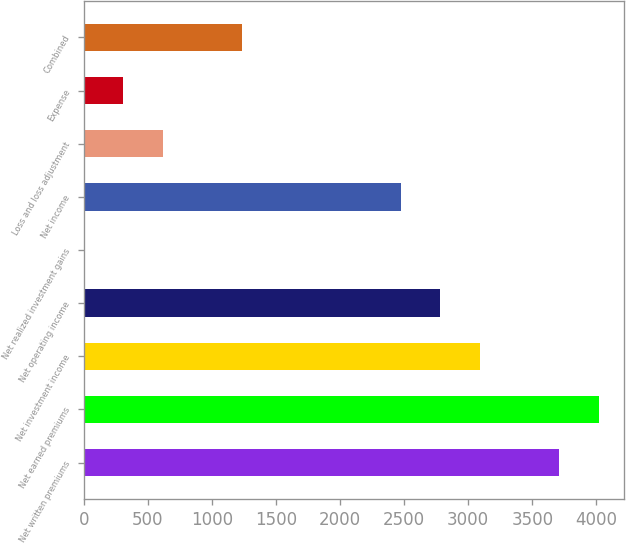Convert chart. <chart><loc_0><loc_0><loc_500><loc_500><bar_chart><fcel>Net written premiums<fcel>Net earned premiums<fcel>Net investment income<fcel>Net operating income<fcel>Net realized investment gains<fcel>Net income<fcel>Loss and loss adjustment<fcel>Expense<fcel>Combined<nl><fcel>3709<fcel>4018<fcel>3091<fcel>2782<fcel>1<fcel>2473<fcel>619<fcel>310<fcel>1237<nl></chart> 